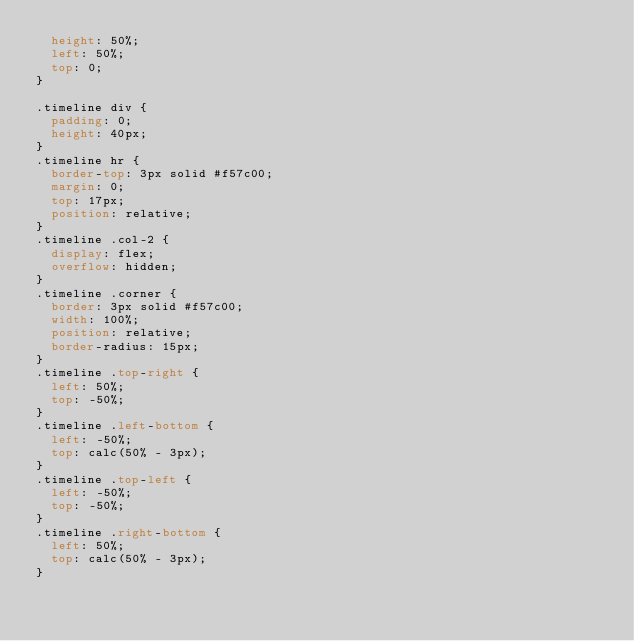Convert code to text. <code><loc_0><loc_0><loc_500><loc_500><_CSS_>  height: 50%;
  left: 50%;
  top: 0;
}

.timeline div {
  padding: 0;
  height: 40px;
}
.timeline hr {
  border-top: 3px solid #f57c00;
  margin: 0;
  top: 17px;
  position: relative;
}
.timeline .col-2 {
  display: flex;
  overflow: hidden;
}
.timeline .corner {
  border: 3px solid #f57c00;
  width: 100%;
  position: relative;
  border-radius: 15px;
}
.timeline .top-right {
  left: 50%;
  top: -50%;
}
.timeline .left-bottom {
  left: -50%;
  top: calc(50% - 3px);
}
.timeline .top-left {
  left: -50%;
  top: -50%;
}
.timeline .right-bottom {
  left: 50%;
  top: calc(50% - 3px);
}
</code> 